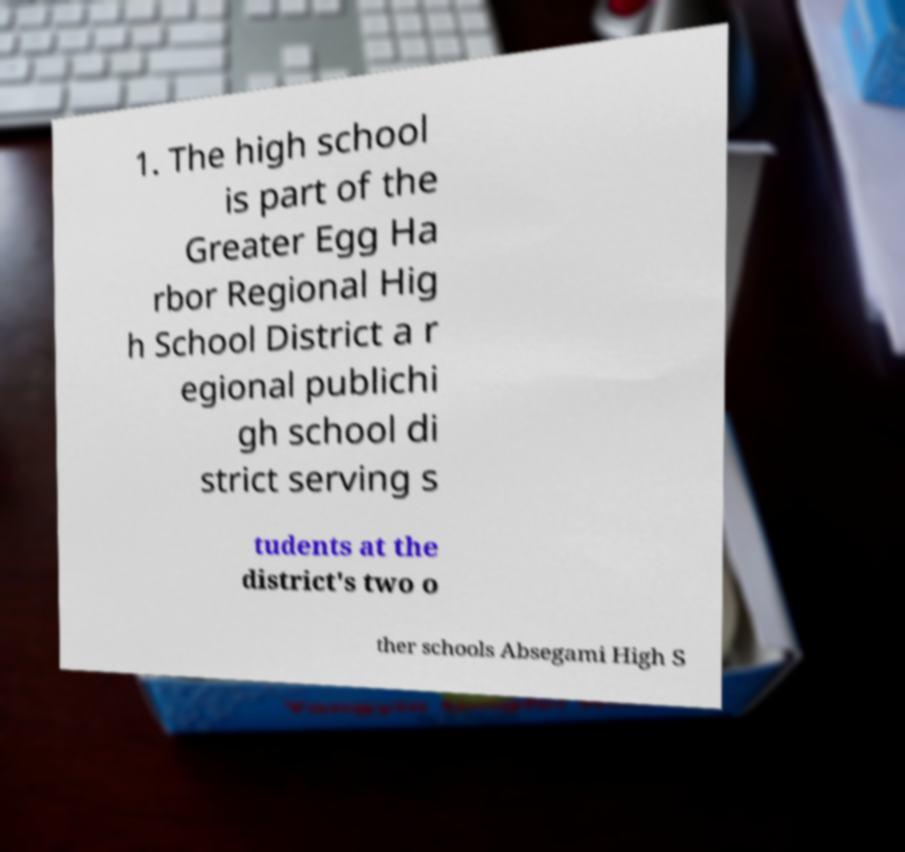I need the written content from this picture converted into text. Can you do that? 1. The high school is part of the Greater Egg Ha rbor Regional Hig h School District a r egional publichi gh school di strict serving s tudents at the district's two o ther schools Absegami High S 